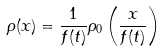<formula> <loc_0><loc_0><loc_500><loc_500>\rho ( x ) = \frac { 1 } { f ( t ) } \rho _ { 0 } \left ( \frac { x } { f ( t ) } \right )</formula> 